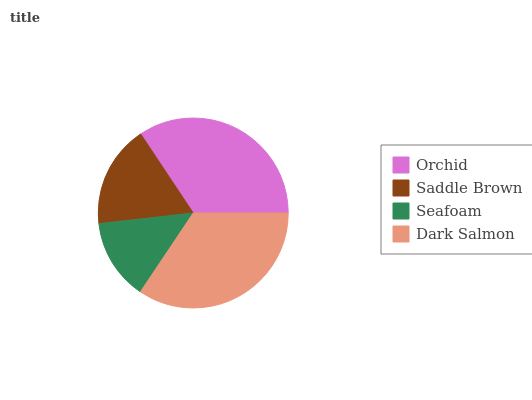Is Seafoam the minimum?
Answer yes or no. Yes. Is Dark Salmon the maximum?
Answer yes or no. Yes. Is Saddle Brown the minimum?
Answer yes or no. No. Is Saddle Brown the maximum?
Answer yes or no. No. Is Orchid greater than Saddle Brown?
Answer yes or no. Yes. Is Saddle Brown less than Orchid?
Answer yes or no. Yes. Is Saddle Brown greater than Orchid?
Answer yes or no. No. Is Orchid less than Saddle Brown?
Answer yes or no. No. Is Orchid the high median?
Answer yes or no. Yes. Is Saddle Brown the low median?
Answer yes or no. Yes. Is Dark Salmon the high median?
Answer yes or no. No. Is Orchid the low median?
Answer yes or no. No. 